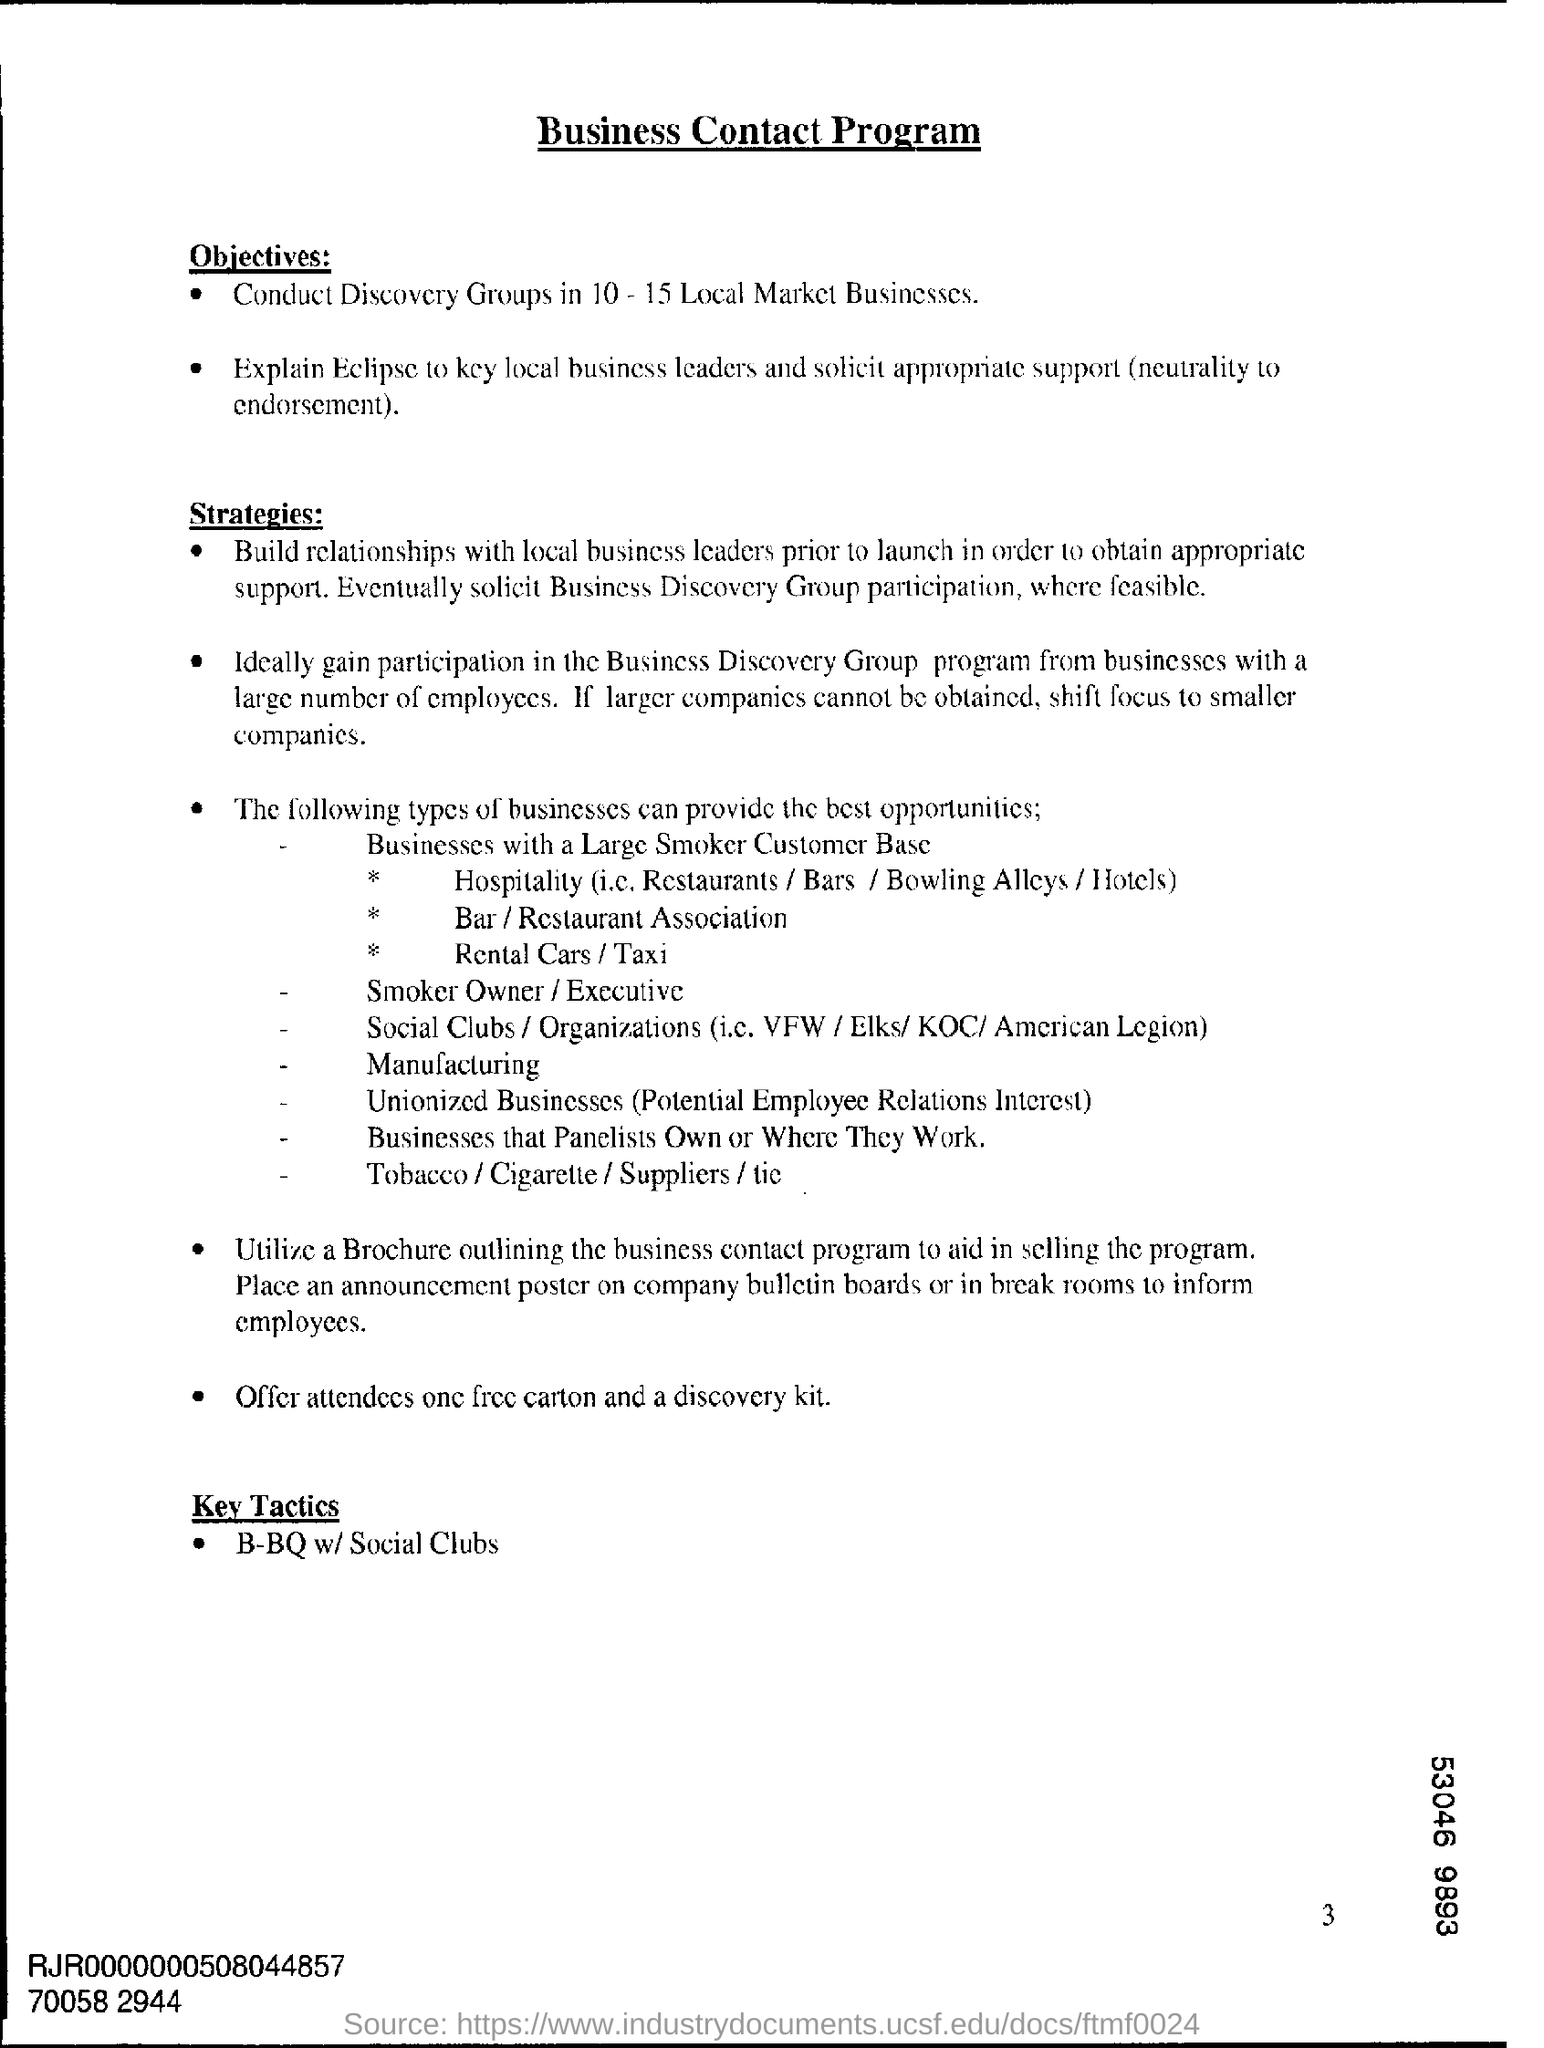What is the first Objective of the Business Contact Program ?
Provide a succinct answer. Conduct Discovery Groups in 10-15 Local Market Businesses. What is the last strategy?
Ensure brevity in your answer.  Offer attendees one free carton and a discovery kit. What is the third heading of the document?
Your response must be concise. Key tactics. 